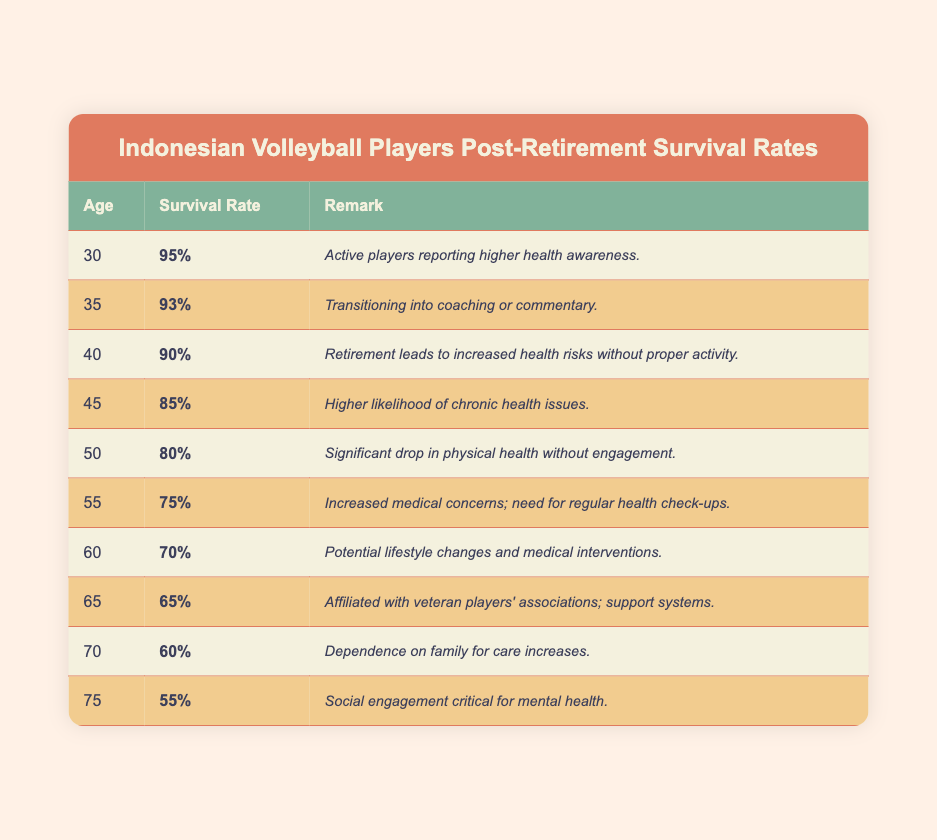What is the survival rate of volleyball players at age 30? The table shows that the survival rate for volleyball players at the age of 30 is listed directly under that age, which is 95%.
Answer: 95% At what age do we see a survival rate below 70%? By reviewing the table, we see that the survival rate falls below 70% starting at age 60, which is 70%, and at age 65 it drops to 65%.
Answer: 65 What is the difference in survival rates between ages 50 and 55? The survival rate for age 50 is 80% and for age 55 it is 75%. The difference is calculated as 80% - 75% = 5%.
Answer: 5% Is the remark for players aged 75 focused on mental health or physical health? The remark for players aged 75 emphasizes that social engagement is critical for mental health, indicating a focus on mental health.
Answer: Yes What is the average survival rate for players aged 40 to 50? To find the average for ages 40, 45, and 50: (90% + 85% + 80%) = 255% and then divide by 3 gives us an average of 85%.
Answer: 85% What survival rate percentage would a player at age 65 need to have to reach the same level as age 60? From the table, the survival rate at age 60 is 70% and at age 65 it is 65%. For a player at age 65 to reach the same survival rate as at age 60, they need to increase from 65% to 70%.
Answer: 70% Does the remark for players aged 40 mention any health risks? The remark for players at age 40 specifies that retirement leads to increased health risks without proper activity, confirming the presence of health risks.
Answer: Yes What is the trend of survival rates as the age increases from 30 to 75? The trends indicate that as age increases from 30 to 75, survival rates consistently decrease, starting at 95% at age 30 and reaching 55% at age 75.
Answer: Decreasing 